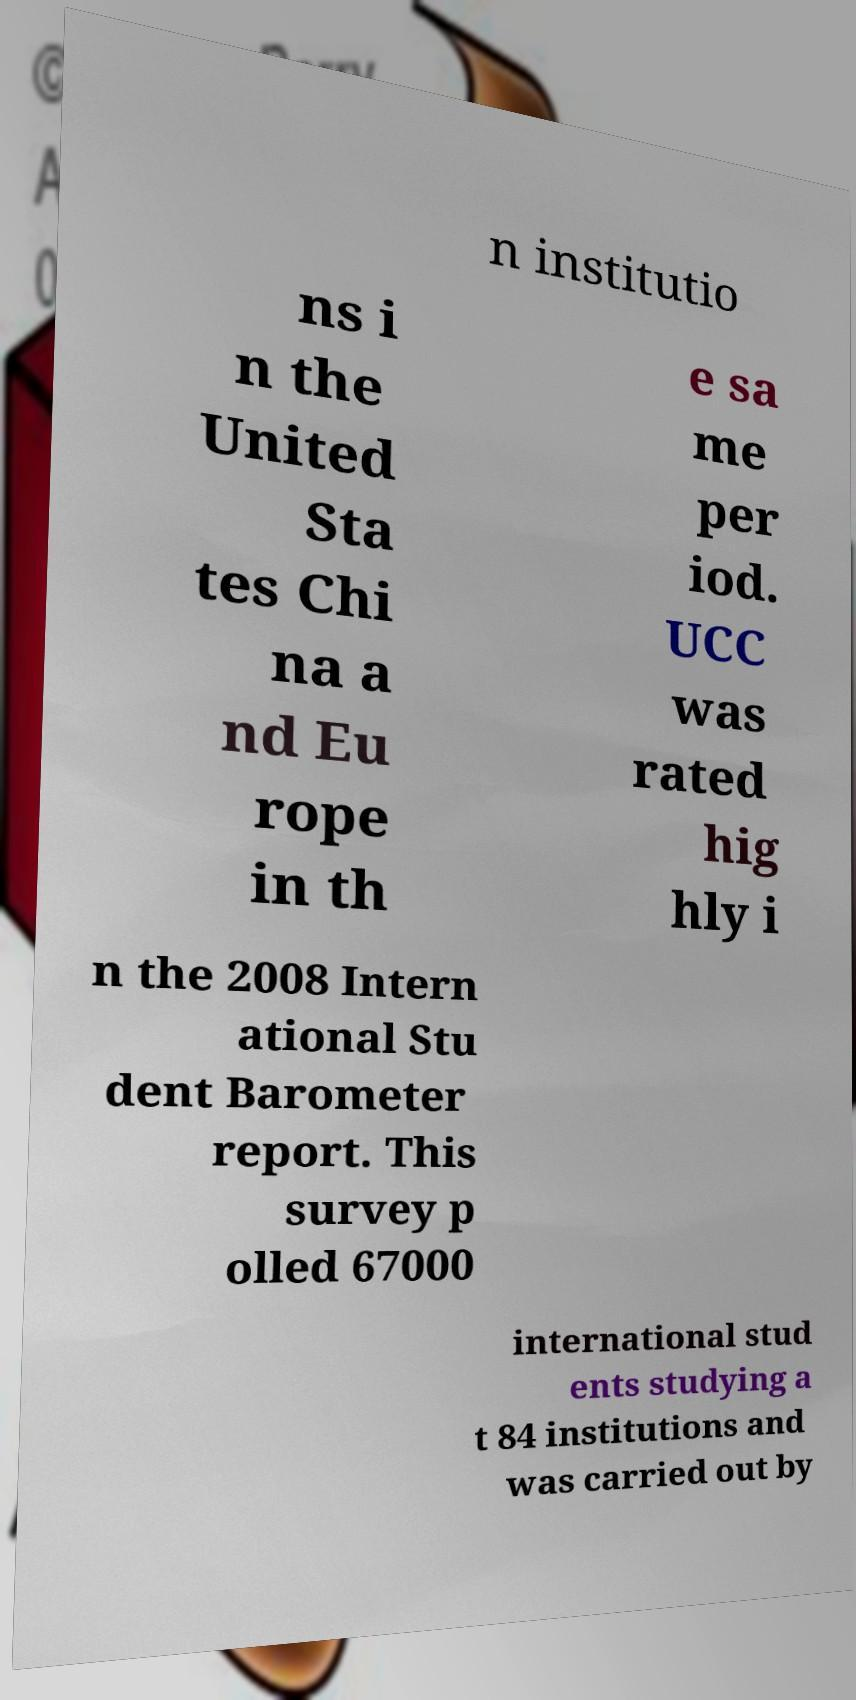For documentation purposes, I need the text within this image transcribed. Could you provide that? n institutio ns i n the United Sta tes Chi na a nd Eu rope in th e sa me per iod. UCC was rated hig hly i n the 2008 Intern ational Stu dent Barometer report. This survey p olled 67000 international stud ents studying a t 84 institutions and was carried out by 